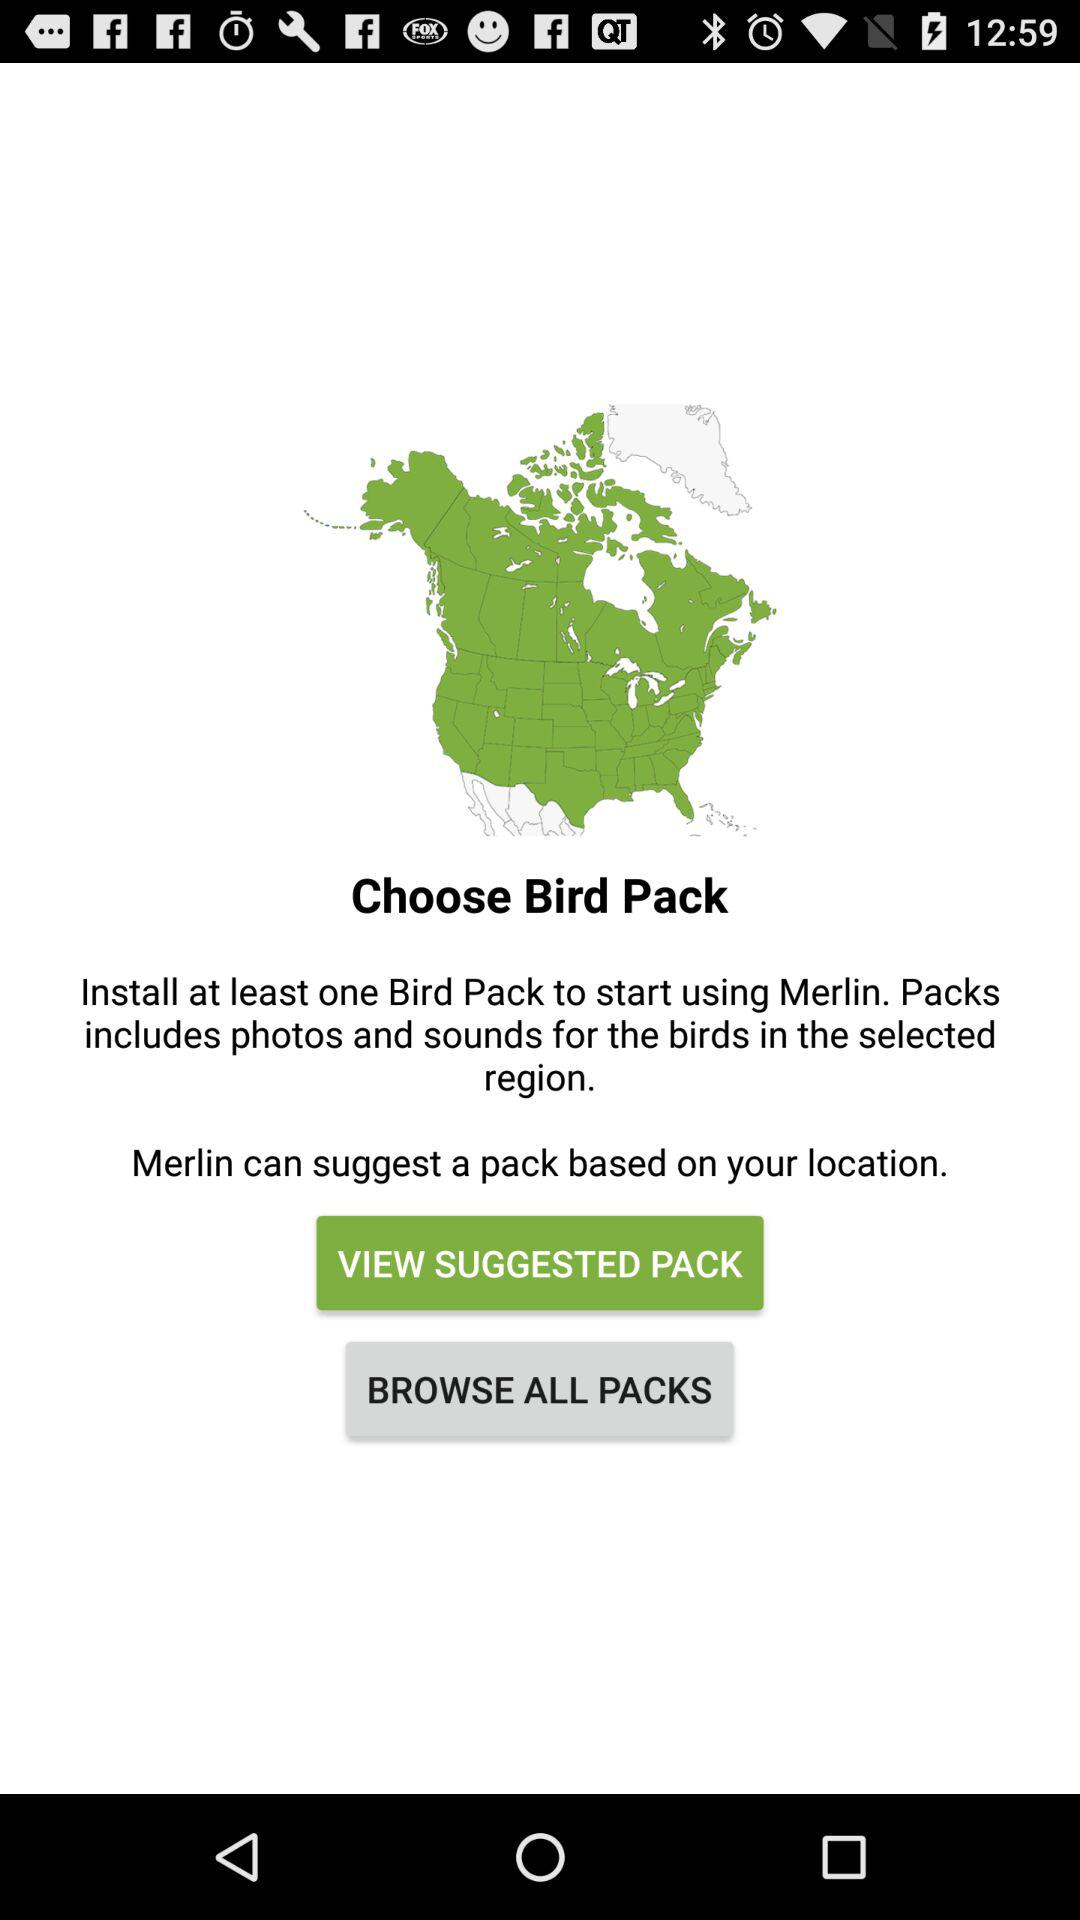What is the name of the application? The name of the application is "Merlin". 